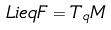<formula> <loc_0><loc_0><loc_500><loc_500>L i e q F = T _ { q } M</formula> 